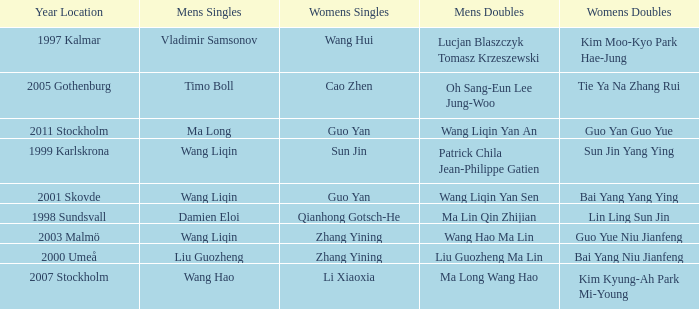How many times has Sun Jin won the women's doubles? 1.0. 